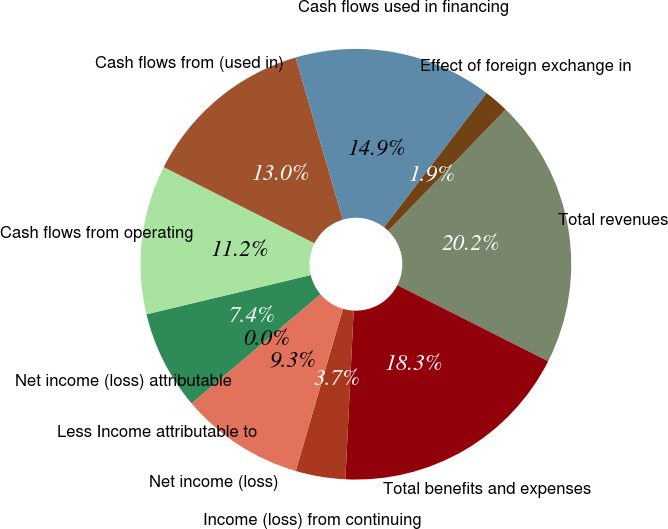<chart> <loc_0><loc_0><loc_500><loc_500><pie_chart><fcel>Total revenues<fcel>Total benefits and expenses<fcel>Income (loss) from continuing<fcel>Net income (loss)<fcel>Less Income attributable to<fcel>Net income (loss) attributable<fcel>Cash flows from operating<fcel>Cash flows from (used in)<fcel>Cash flows used in financing<fcel>Effect of foreign exchange in<nl><fcel>20.2%<fcel>18.34%<fcel>3.73%<fcel>9.31%<fcel>0.0%<fcel>7.45%<fcel>11.18%<fcel>13.04%<fcel>14.9%<fcel>1.86%<nl></chart> 